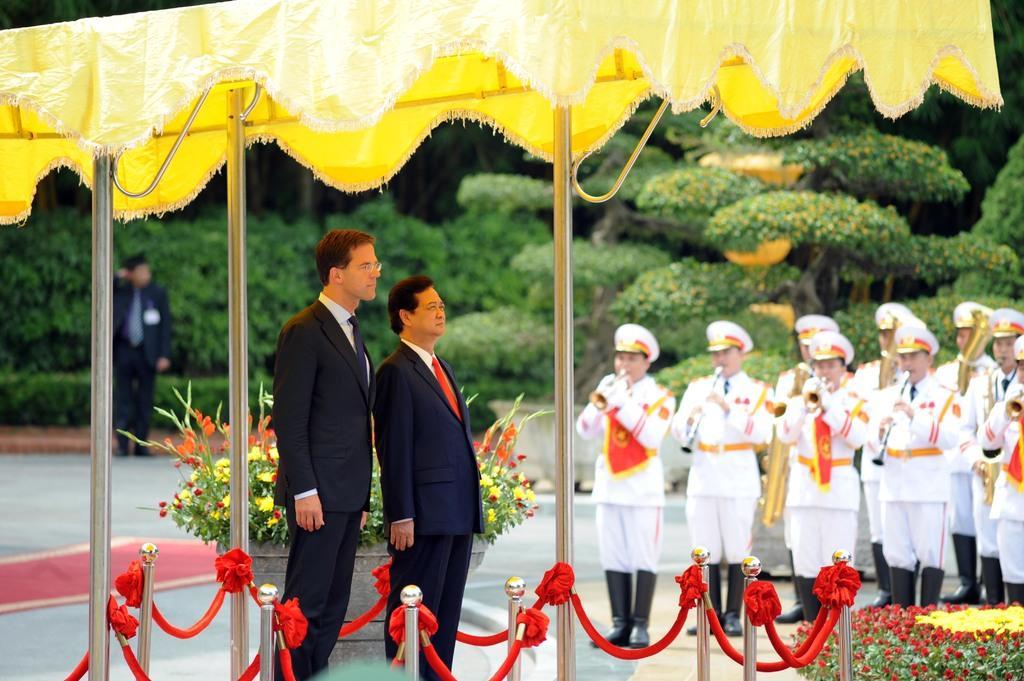Could you give a brief overview of what you see in this image? In this picture we can see two men standing. There are a few rods, red objects on these rods and a flower pot at the back of these two men. We can see some flowers in the bottom right. There are a few people playing musical instruments on the right side. We can see a person standing on the path at the back. There is a red carpet on the floor on the left side. We can see a few plants, trees and other objects in the background. 